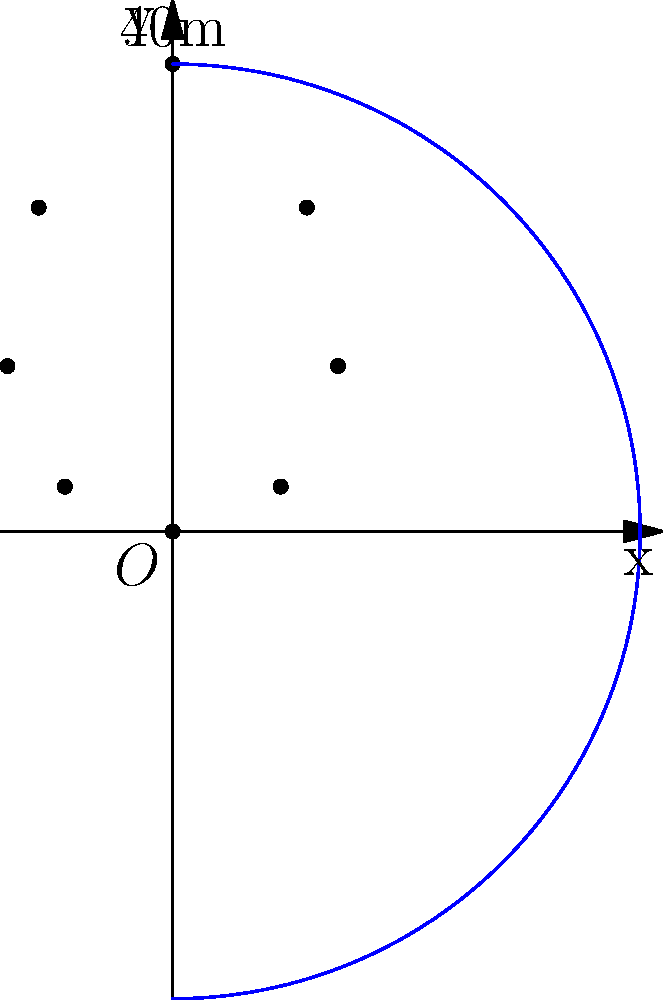As an aspiring sports reporter, you're analyzing a spectacular soccer kick. The trajectory of the ball can be modeled using polar coordinates, where $r = 40\sin\theta$ meters and $\theta$ ranges from 0 to $\pi$ radians. What is the maximum height reached by the ball during its flight? To find the maximum height of the ball's trajectory, we need to follow these steps:

1) In polar coordinates, the height corresponds to the y-coordinate, which is given by $y = r\sin\theta$.

2) Substituting the given equation for $r$, we get:
   $y = (40\sin\theta)\sin\theta = 40\sin^2\theta$

3) To find the maximum value of $y$, we need to find the maximum value of $\sin^2\theta$.

4) We know that $\sin\theta$ reaches its maximum value of 1 when $\theta = \frac{\pi}{2}$.

5) At this point, $\sin^2\theta = 1^2 = 1$.

6) Therefore, the maximum height is reached when $\theta = \frac{\pi}{2}$, and its value is:
   $y_{max} = 40 \cdot 1 = 40$ meters.

Thus, the maximum height reached by the ball during its flight is 40 meters.
Answer: 40 meters 